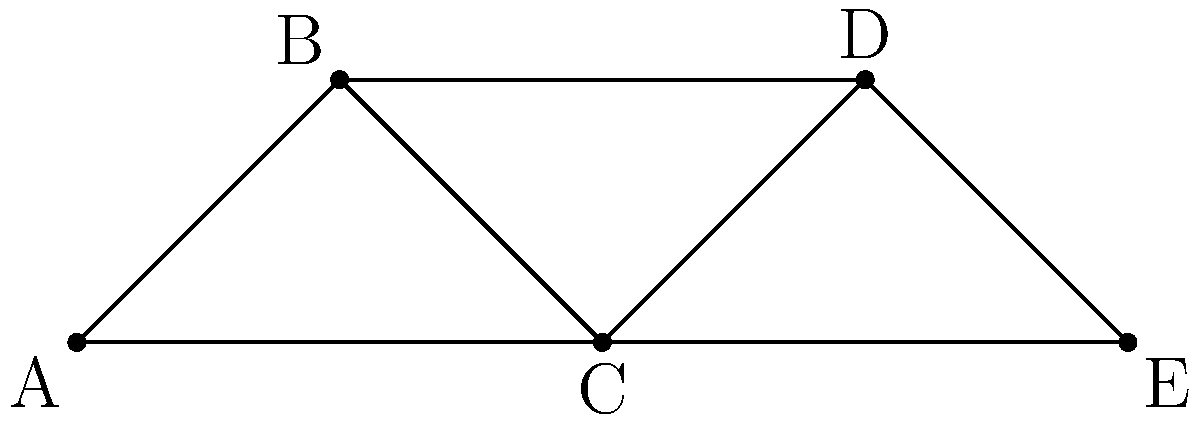In this customer relationship management (CRM) social network graph, each node represents a customer, and edges represent interactions or relationships between customers. Assuming you want to identify the most influential customer for a targeted marketing campaign using Kaseya VSA, which node has the highest degree centrality? To solve this problem, we need to understand the concept of degree centrality in graph theory and how it applies to CRM in the context of small business management using Kaseya VSA.

Step 1: Understand degree centrality
Degree centrality is a measure of the number of connections (edges) a node has in a graph. In a CRM context, this represents the number of direct relationships a customer has with other customers.

Step 2: Count the connections for each node
A: 2 connections
B: 2 connections
C: 4 connections
D: 2 connections
E: 2 connections

Step 3: Identify the node with the highest degree centrality
Node C has the highest number of connections (4), making it the node with the highest degree centrality.

Step 4: Interpret the result
In the context of CRM and using Kaseya VSA for small business management, the customer represented by node C would be considered the most influential in this network. This customer has the most direct connections to other customers, potentially making them a valuable target for marketing campaigns or customer retention strategies.

Step 5: Apply this knowledge to Kaseya VSA
Using Kaseya VSA, you can create a targeted automation policy or script to prioritize communications or service delivery to this high-value customer. This could involve setting up custom alerts, scheduling more frequent check-ins, or offering personalized promotions to leverage their influence in the customer network.
Answer: Node C 